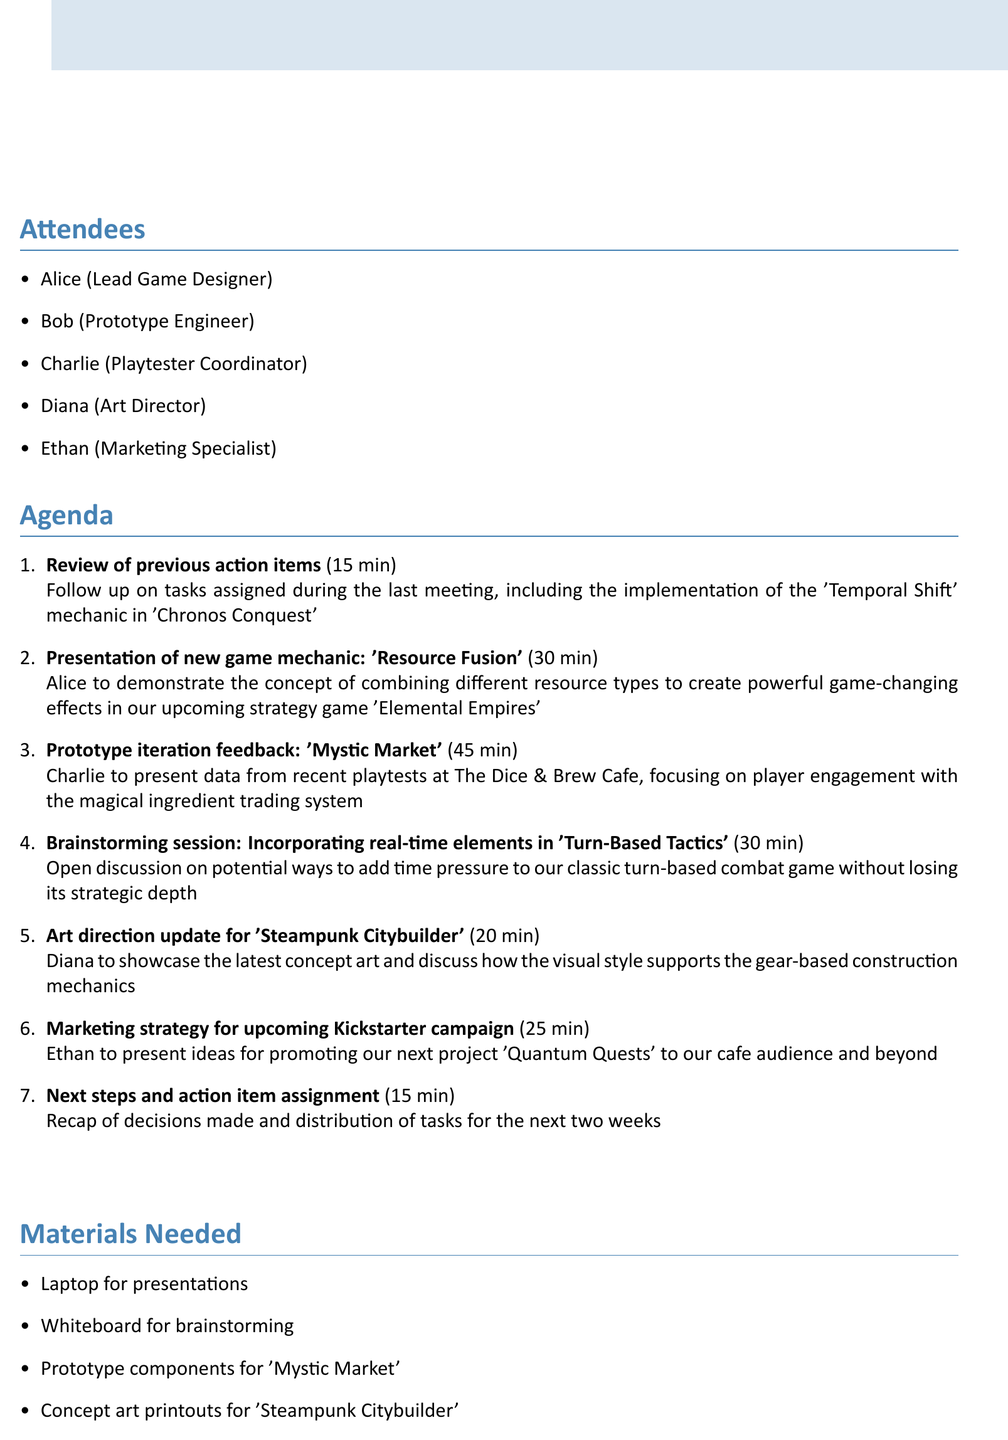What is the date and time of the meeting? The date and time of the meeting is explicitly mentioned in the document.
Answer: Thursday, May 18th, 2023, 2:00 PM - 4:00 PM Who is the Lead Game Designer? The attendees list specifies the role of each person, including the Lead Game Designer.
Answer: Alice How long is the presentation of the new game mechanic? The duration for the presentation is stated in the agenda item details.
Answer: 30 minutes What is one of the materials needed for the meeting? The document outlines a list of materials required for the meeting.
Answer: Laptop for presentations What is the title of the game being presented for prototype iteration feedback? The title of the game is indicated in the corresponding agenda item regarding prototype iteration feedback.
Answer: Mystic Market How many attendees are there in total? The total number of attendees can be counted from the attendees section of the document.
Answer: 5 What is one post-meeting activity planned? The document includes specific post-meeting activities that will be conducted.
Answer: Informal playtesting session of 'Chronos Conquest' Which game is associated with the new mechanic 'Resource Fusion'? The document mentions the game alongside the new mechanic presentation.
Answer: Elemental Empires 